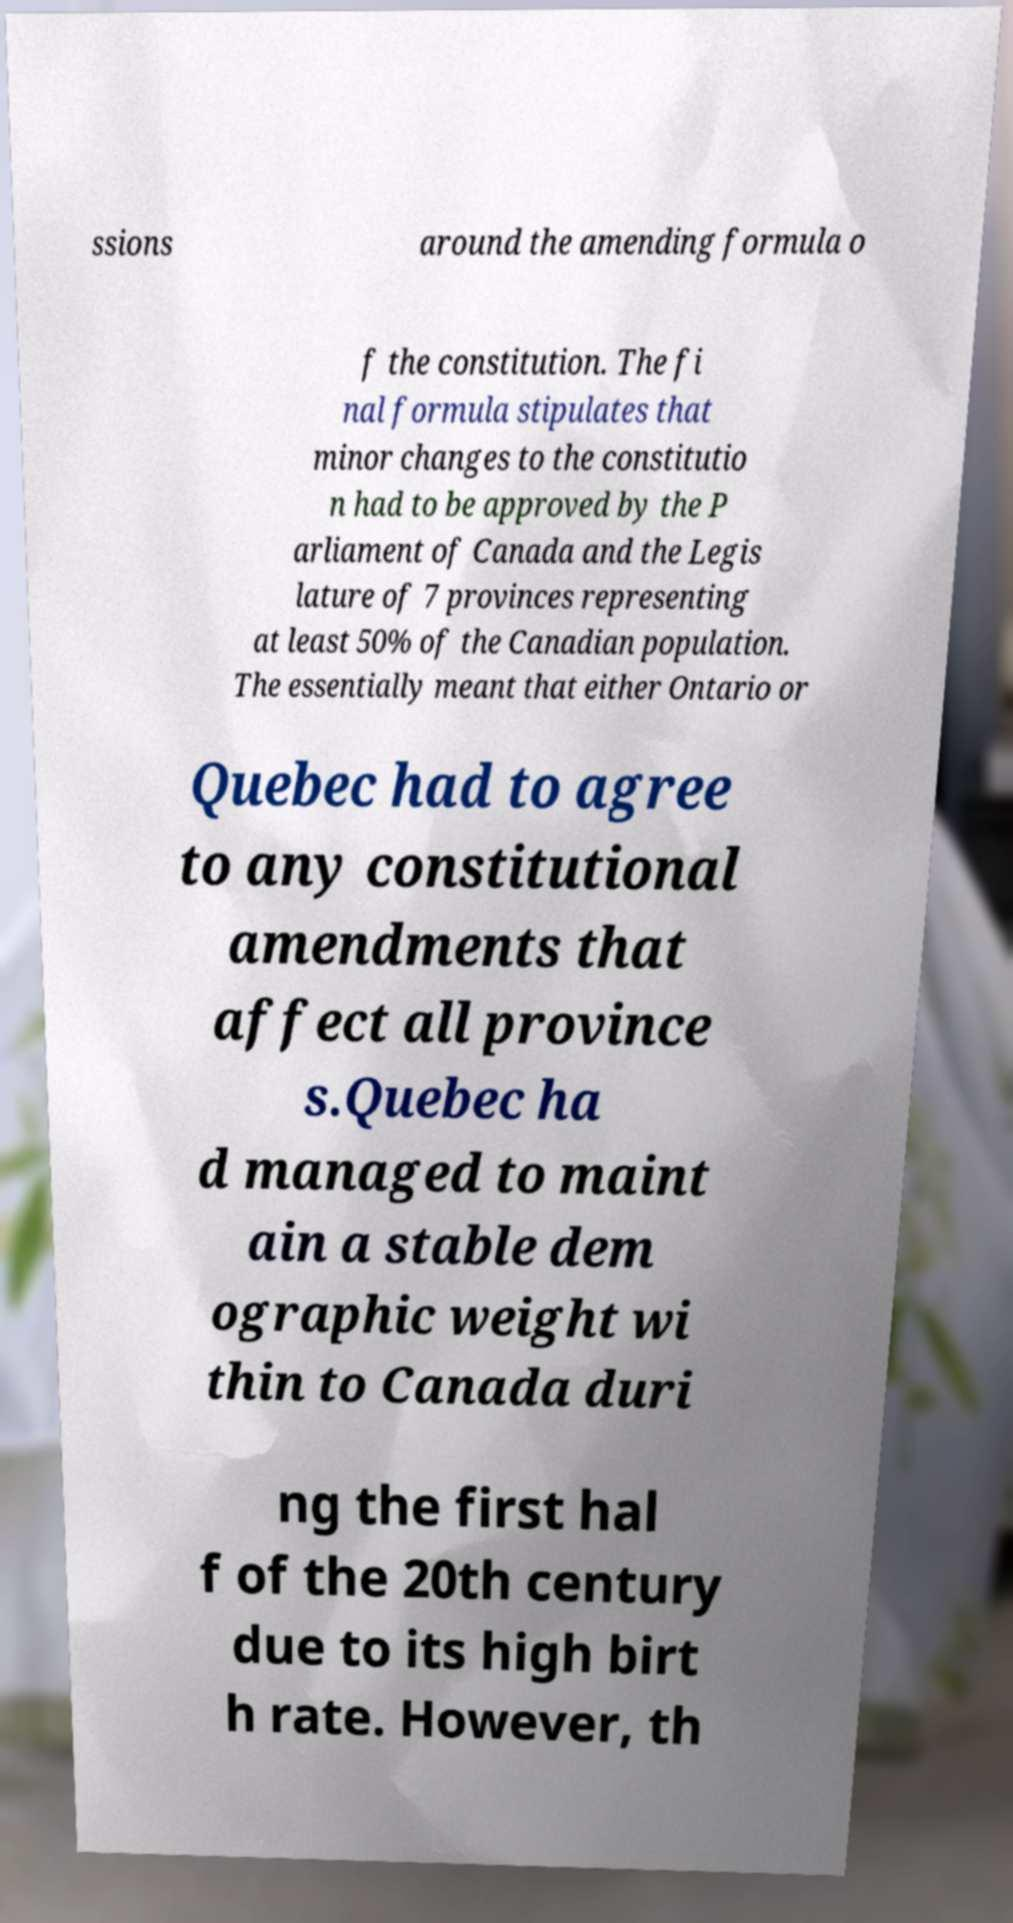What messages or text are displayed in this image? I need them in a readable, typed format. ssions around the amending formula o f the constitution. The fi nal formula stipulates that minor changes to the constitutio n had to be approved by the P arliament of Canada and the Legis lature of 7 provinces representing at least 50% of the Canadian population. The essentially meant that either Ontario or Quebec had to agree to any constitutional amendments that affect all province s.Quebec ha d managed to maint ain a stable dem ographic weight wi thin to Canada duri ng the first hal f of the 20th century due to its high birt h rate. However, th 